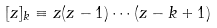Convert formula to latex. <formula><loc_0><loc_0><loc_500><loc_500>[ z ] _ { k } \equiv z ( z - 1 ) \cdots ( z - k + 1 )</formula> 